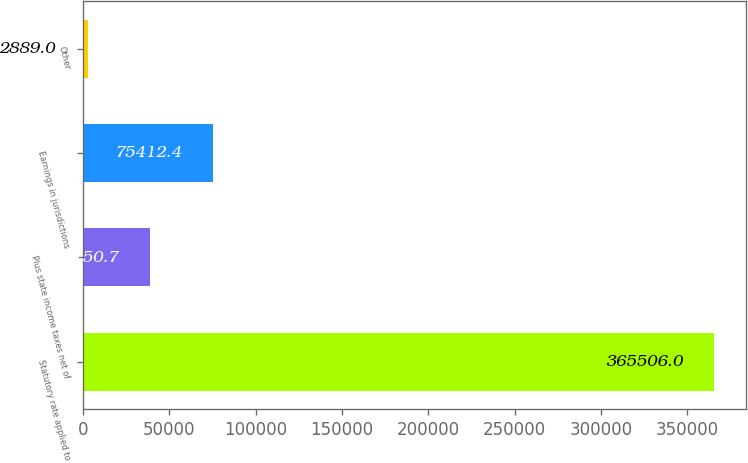Convert chart to OTSL. <chart><loc_0><loc_0><loc_500><loc_500><bar_chart><fcel>Statutory rate applied to<fcel>Plus state income taxes net of<fcel>Earnings in jurisdictions<fcel>Other<nl><fcel>365506<fcel>39150.7<fcel>75412.4<fcel>2889<nl></chart> 